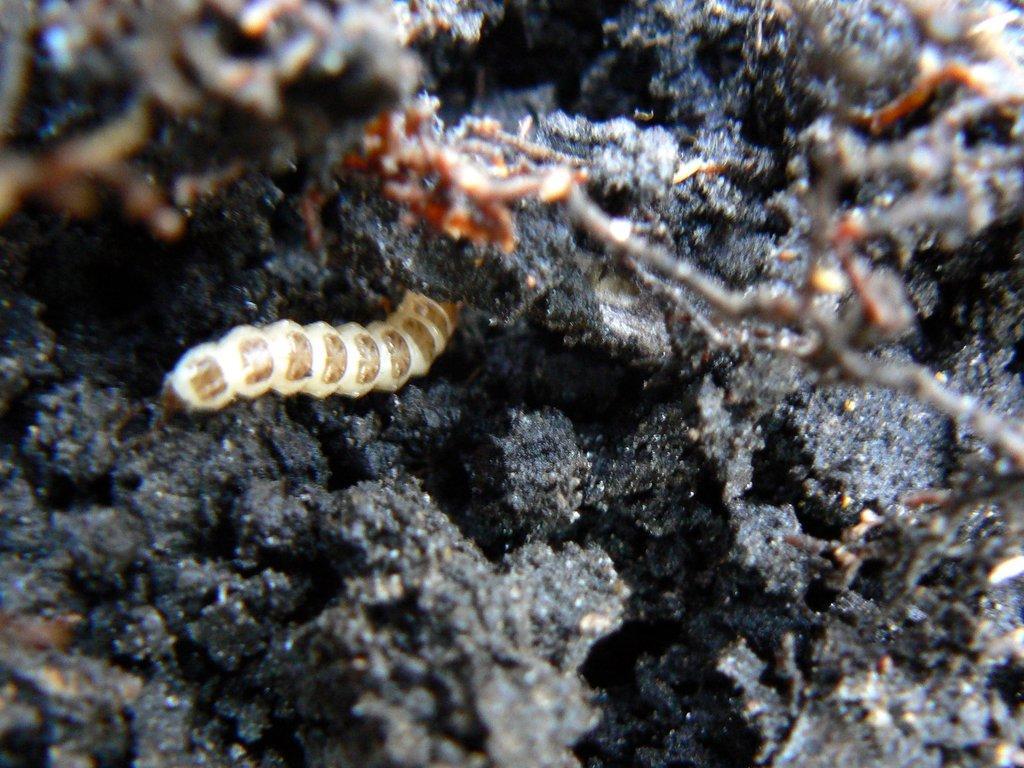Can you describe this image briefly? In this image we can see a insect on the rock. 